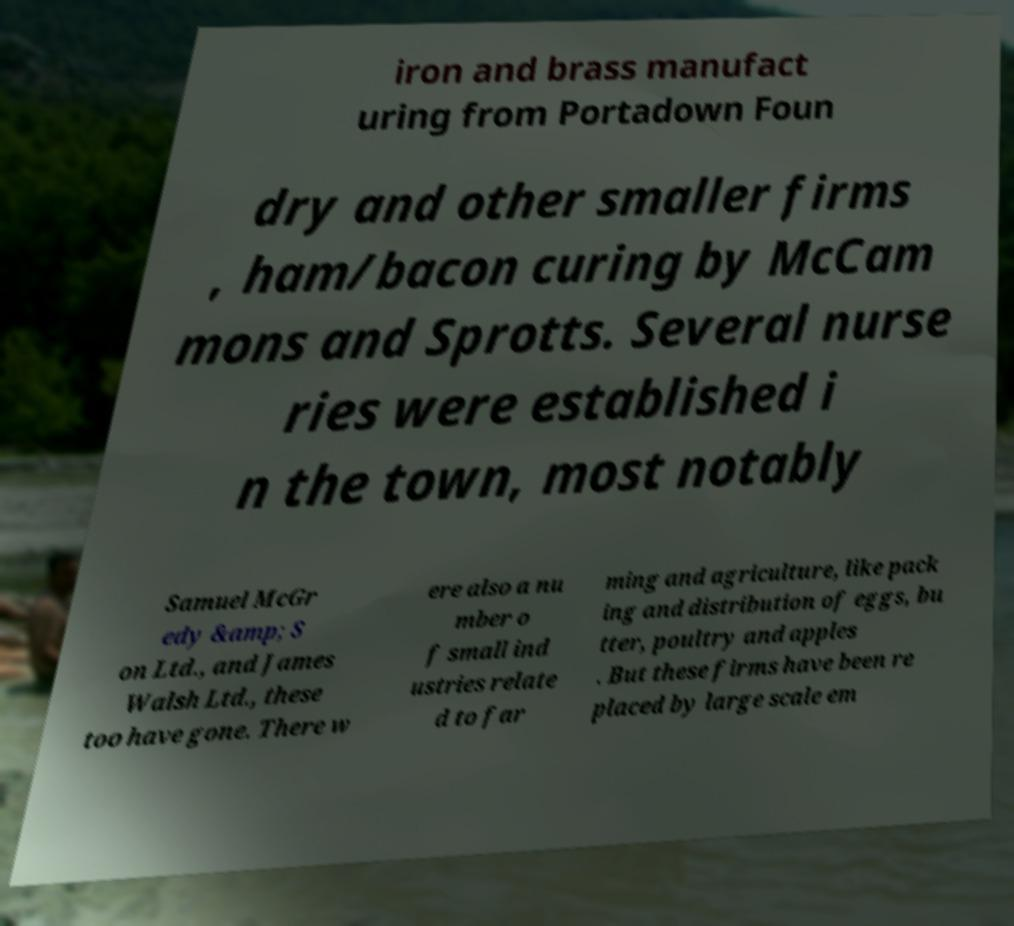Could you extract and type out the text from this image? iron and brass manufact uring from Portadown Foun dry and other smaller firms , ham/bacon curing by McCam mons and Sprotts. Several nurse ries were established i n the town, most notably Samuel McGr edy &amp; S on Ltd., and James Walsh Ltd., these too have gone. There w ere also a nu mber o f small ind ustries relate d to far ming and agriculture, like pack ing and distribution of eggs, bu tter, poultry and apples . But these firms have been re placed by large scale em 